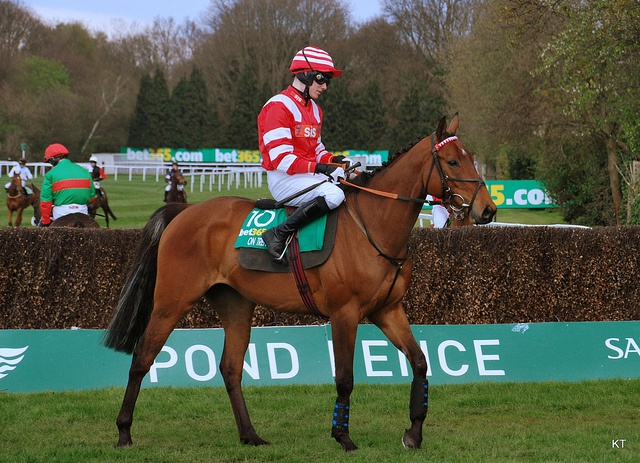Describe the objects in this image and their specific colors. I can see horse in gray, maroon, black, and brown tones, people in gray, black, lavender, and brown tones, people in gray, green, turquoise, salmon, and black tones, horse in gray, black, maroon, and olive tones, and horse in gray, black, and maroon tones in this image. 